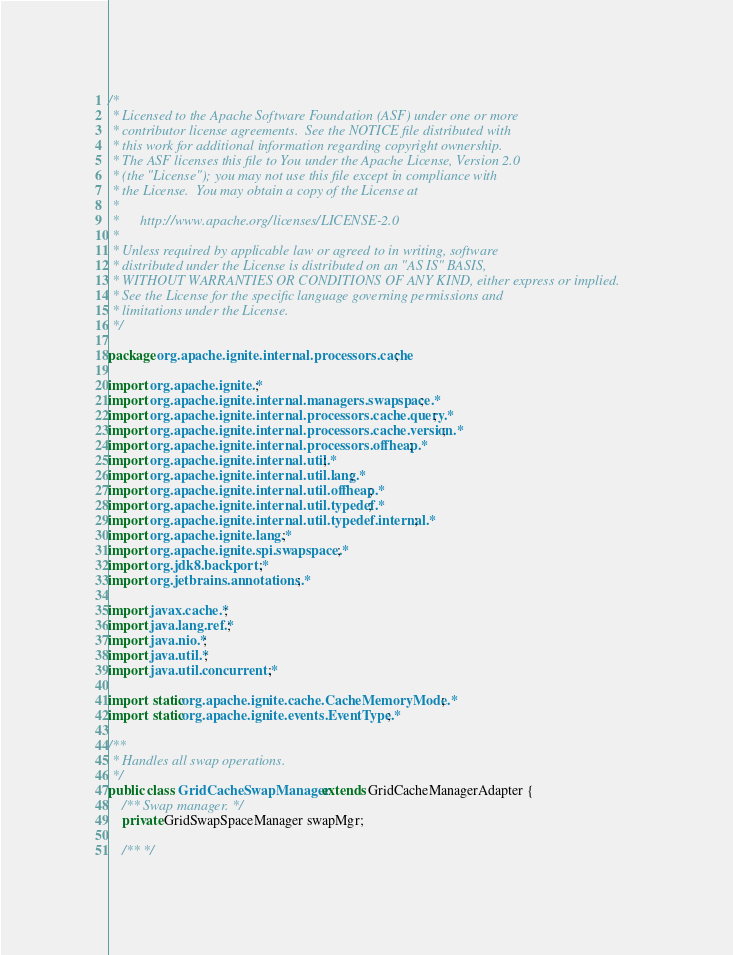Convert code to text. <code><loc_0><loc_0><loc_500><loc_500><_Java_>/*
 * Licensed to the Apache Software Foundation (ASF) under one or more
 * contributor license agreements.  See the NOTICE file distributed with
 * this work for additional information regarding copyright ownership.
 * The ASF licenses this file to You under the Apache License, Version 2.0
 * (the "License"); you may not use this file except in compliance with
 * the License.  You may obtain a copy of the License at
 *
 *      http://www.apache.org/licenses/LICENSE-2.0
 *
 * Unless required by applicable law or agreed to in writing, software
 * distributed under the License is distributed on an "AS IS" BASIS,
 * WITHOUT WARRANTIES OR CONDITIONS OF ANY KIND, either express or implied.
 * See the License for the specific language governing permissions and
 * limitations under the License.
 */

package org.apache.ignite.internal.processors.cache;

import org.apache.ignite.*;
import org.apache.ignite.internal.managers.swapspace.*;
import org.apache.ignite.internal.processors.cache.query.*;
import org.apache.ignite.internal.processors.cache.version.*;
import org.apache.ignite.internal.processors.offheap.*;
import org.apache.ignite.internal.util.*;
import org.apache.ignite.internal.util.lang.*;
import org.apache.ignite.internal.util.offheap.*;
import org.apache.ignite.internal.util.typedef.*;
import org.apache.ignite.internal.util.typedef.internal.*;
import org.apache.ignite.lang.*;
import org.apache.ignite.spi.swapspace.*;
import org.jdk8.backport.*;
import org.jetbrains.annotations.*;

import javax.cache.*;
import java.lang.ref.*;
import java.nio.*;
import java.util.*;
import java.util.concurrent.*;

import static org.apache.ignite.cache.CacheMemoryMode.*;
import static org.apache.ignite.events.EventType.*;

/**
 * Handles all swap operations.
 */
public class GridCacheSwapManager extends GridCacheManagerAdapter {
    /** Swap manager. */
    private GridSwapSpaceManager swapMgr;

    /** */</code> 